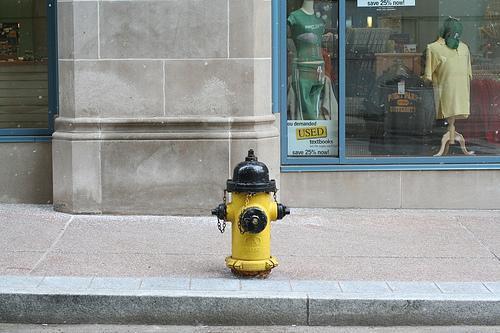How many hydrants?
Give a very brief answer. 1. 